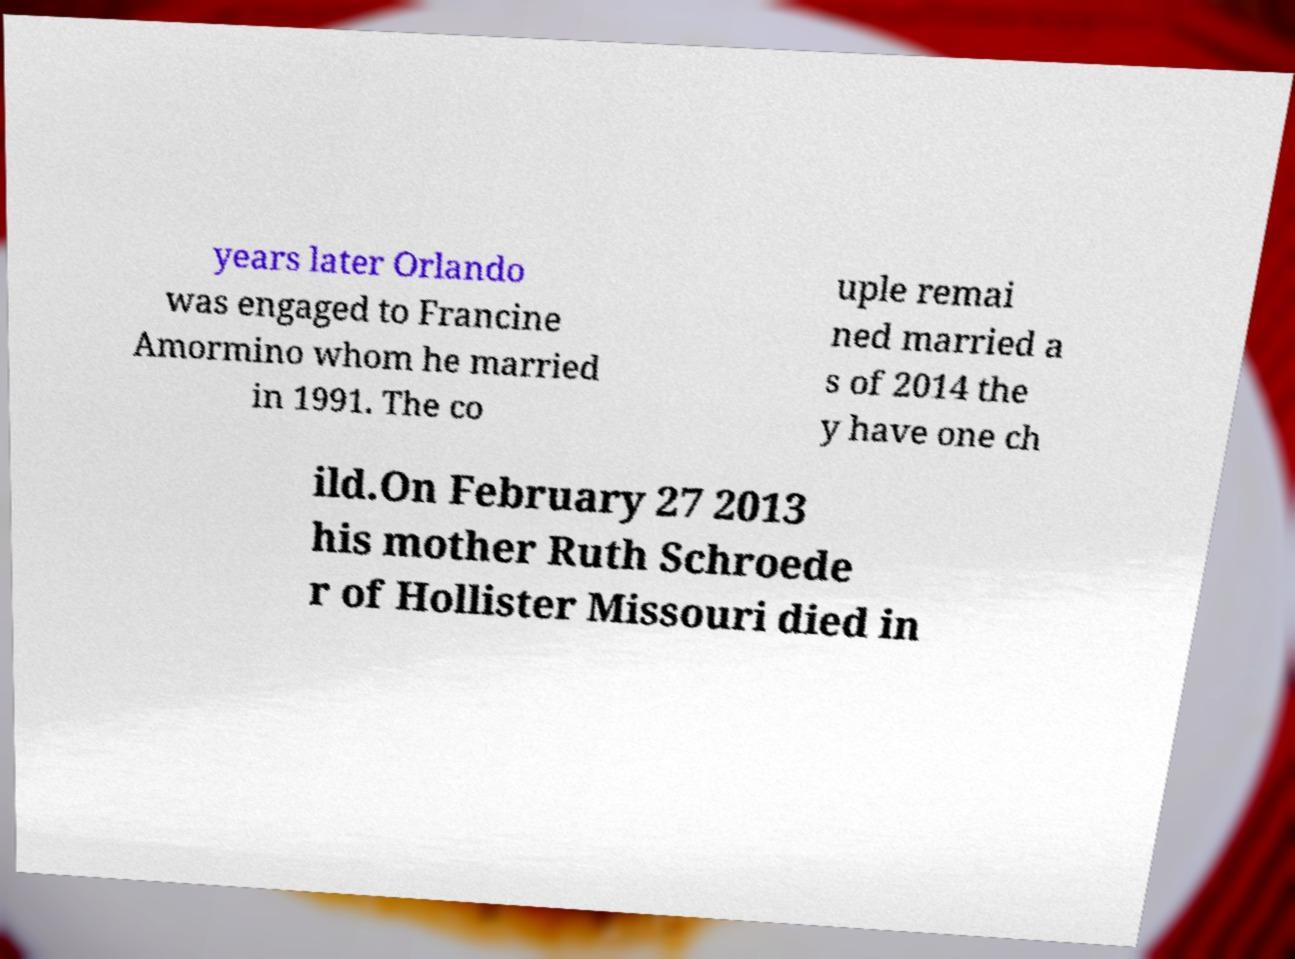Please read and relay the text visible in this image. What does it say? years later Orlando was engaged to Francine Amormino whom he married in 1991. The co uple remai ned married a s of 2014 the y have one ch ild.On February 27 2013 his mother Ruth Schroede r of Hollister Missouri died in 